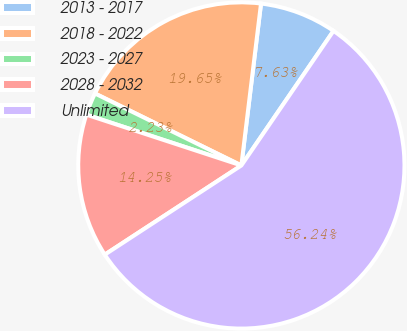Convert chart. <chart><loc_0><loc_0><loc_500><loc_500><pie_chart><fcel>2013 - 2017<fcel>2018 - 2022<fcel>2023 - 2027<fcel>2028 - 2032<fcel>Unlimited<nl><fcel>7.63%<fcel>19.65%<fcel>2.23%<fcel>14.25%<fcel>56.24%<nl></chart> 